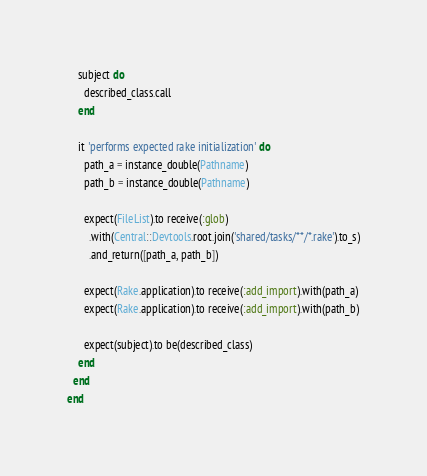<code> <loc_0><loc_0><loc_500><loc_500><_Ruby_>    subject do
      described_class.call
    end

    it 'performs expected rake initialization' do
      path_a = instance_double(Pathname)
      path_b = instance_double(Pathname)

      expect(FileList).to receive(:glob)
        .with(Central::Devtools.root.join('shared/tasks/**/*.rake').to_s)
        .and_return([path_a, path_b])

      expect(Rake.application).to receive(:add_import).with(path_a)
      expect(Rake.application).to receive(:add_import).with(path_b)

      expect(subject).to be(described_class)
    end
  end
end
</code> 